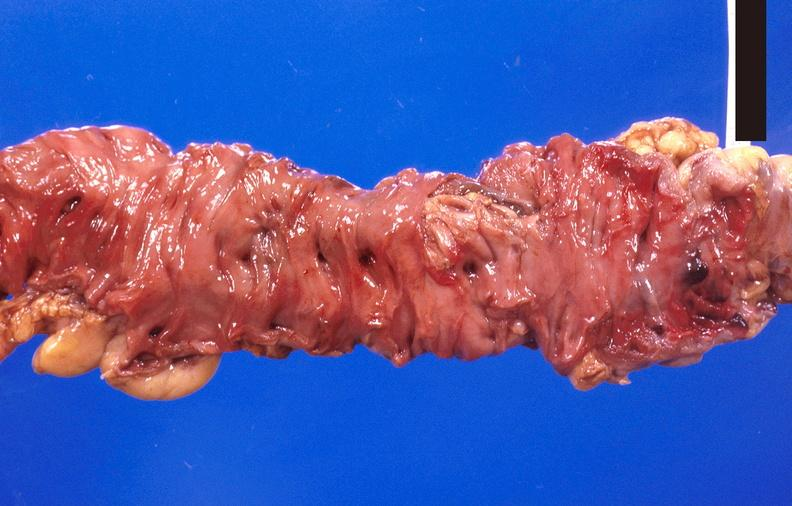what is present?
Answer the question using a single word or phrase. Gastrointestinal 